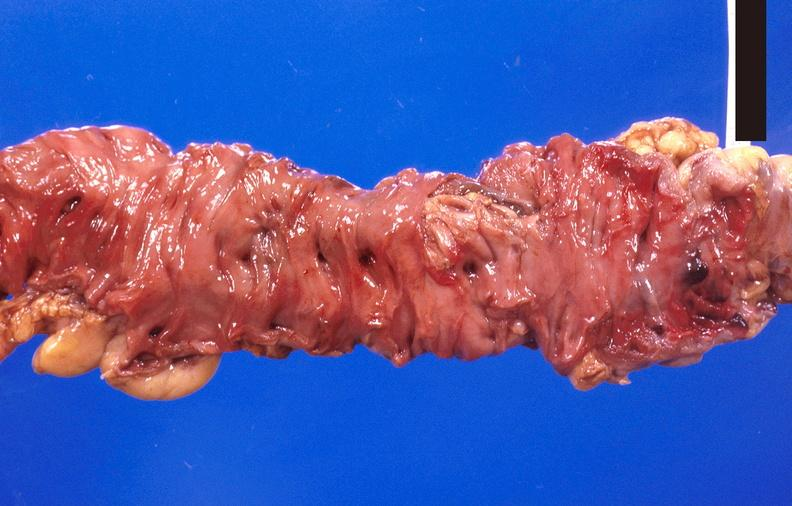what is present?
Answer the question using a single word or phrase. Gastrointestinal 